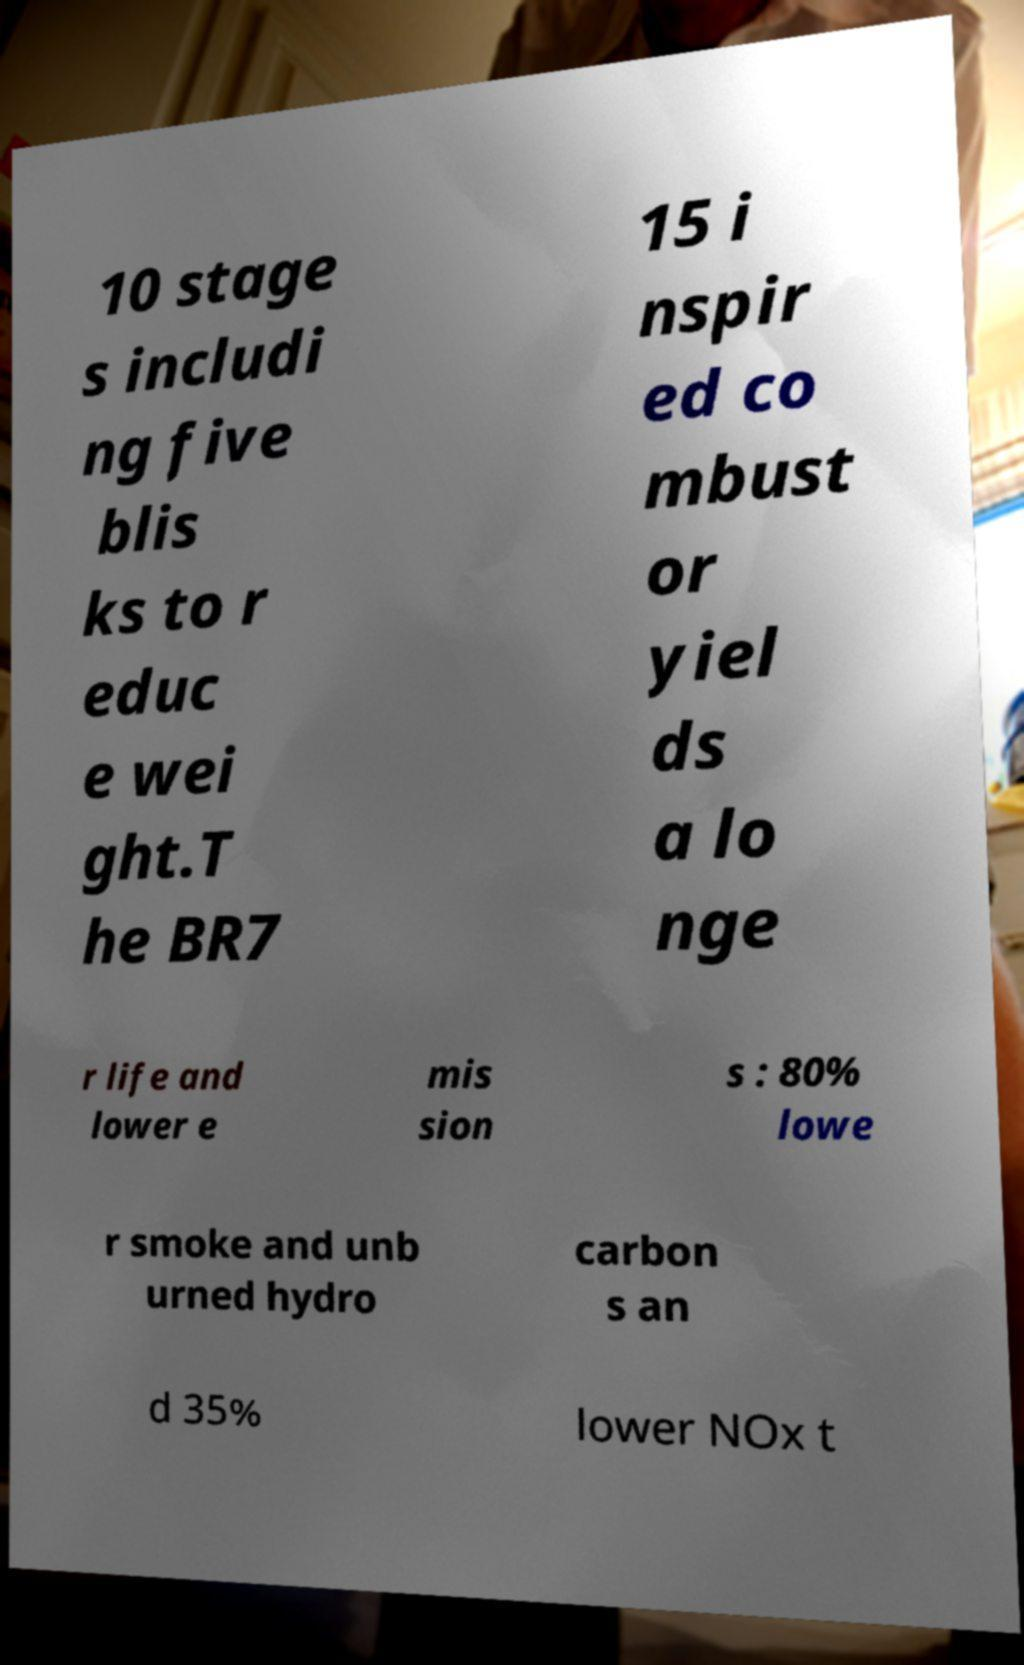Please read and relay the text visible in this image. What does it say? 10 stage s includi ng five blis ks to r educ e wei ght.T he BR7 15 i nspir ed co mbust or yiel ds a lo nge r life and lower e mis sion s : 80% lowe r smoke and unb urned hydro carbon s an d 35% lower NOx t 